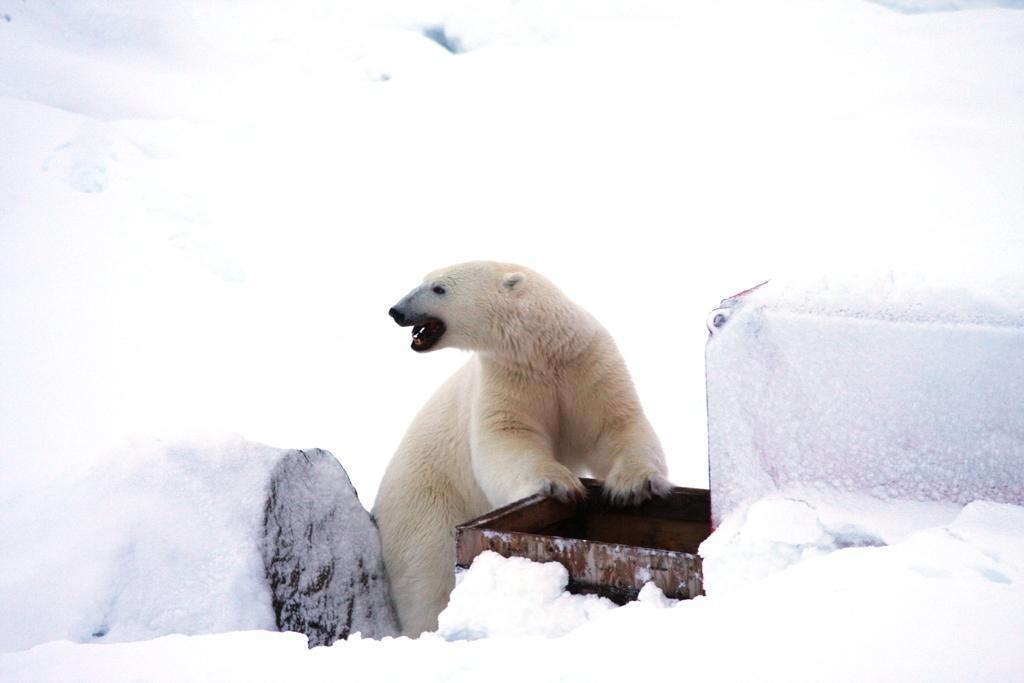Please provide a concise description of this image. In this picture I can observe polar bear in the middle of the picture. In the background I can observe snow on the land. 